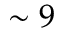Convert formula to latex. <formula><loc_0><loc_0><loc_500><loc_500>\sim 9</formula> 